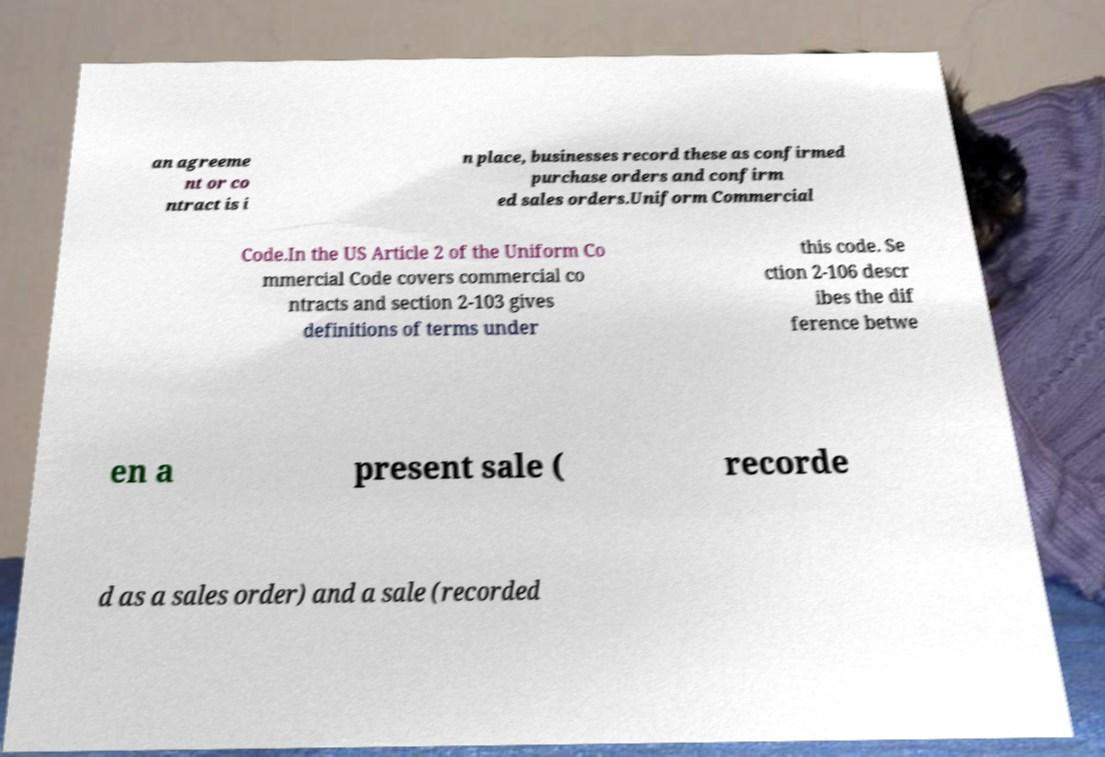Can you accurately transcribe the text from the provided image for me? an agreeme nt or co ntract is i n place, businesses record these as confirmed purchase orders and confirm ed sales orders.Uniform Commercial Code.In the US Article 2 of the Uniform Co mmercial Code covers commercial co ntracts and section 2-103 gives definitions of terms under this code. Se ction 2-106 descr ibes the dif ference betwe en a present sale ( recorde d as a sales order) and a sale (recorded 